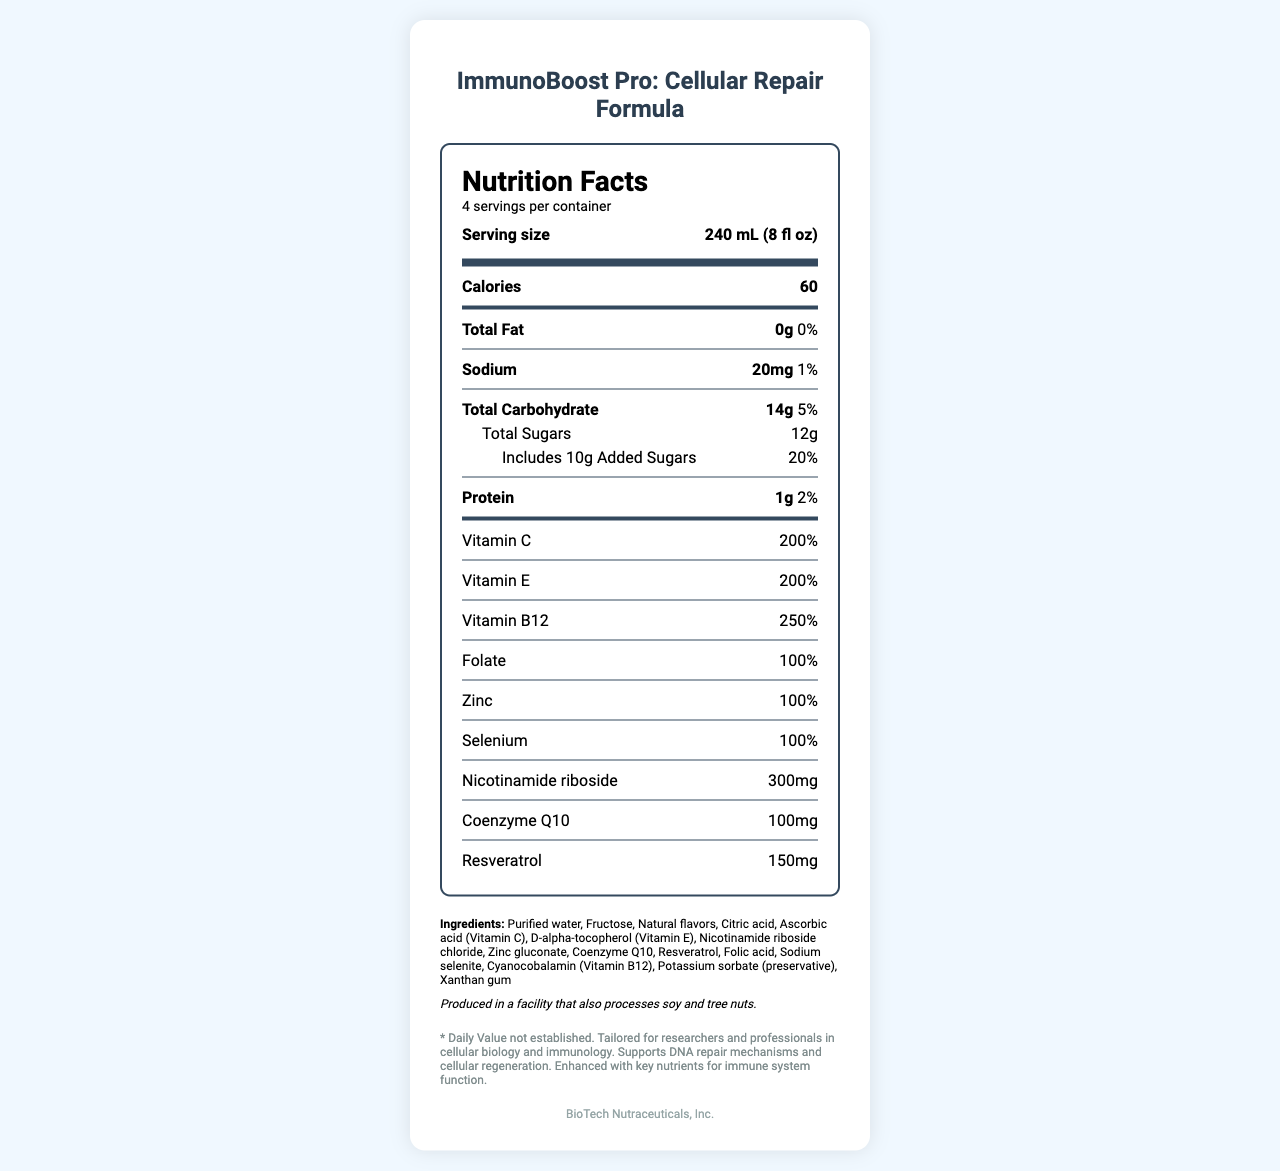what is the serving size? The serving size is displayed at the top of the Nutrition Facts label under "Serving size".
Answer: 240 mL (8 fl oz) how many calories are in one serving? The number of calories per serving is listed near the top of the Nutrition Facts section.
Answer: 60 name three vitamins found in this product and their daily values. The daily values for Vitamin C, Vitamin E, and Vitamin B12 are clearly listed in the vitamins section of the label.
Answer: Vitamin C (200%), Vitamin E (200%), Vitamin B12 (250%) what is the total fat content per serving? The total fat content per serving is listed as 0g.
Answer: 0g how many grams of sugar are added sugars? The document specifies that 10g of the total sugars are added sugars.
Answer: 10g how many servings are in one container? The number of servings per container is listed as 4.
Answer: 4 what are the ingredients in the product? All the ingredients are listed under the "Ingredients" section of the label.
Answer: Purified water, Fructose, Natural flavors, Citric acid, Ascorbic acid (Vitamin C), D-alpha-tocopherol (Vitamin E), Nicotinamide riboside chloride, Zinc gluconate, Coenzyme Q10, Resveratrol, Folic acid, Sodium selenite, Cyanocobalamin (Vitamin B12), Potassium sorbate (preservative), Xanthan gum what is the daily value percentage of protein in one serving? The daily value percentage for protein is listed as 2% in the Nutrition Facts.
Answer: 2% which vitamin has the highest percentage of daily value in one serving? A. Vitamin C B. Vitamin E C. Vitamin B12 The daily value percentage for Vitamin B12 is 250%, which is higher than both Vitamin C (200%) and Vitamin E (200%).
Answer: C. Vitamin B12 what is the daily value percentage for sodium? A. 0.5% B. 1% C. 2% D. 5% The daily value percentage for sodium is listed as 1%.
Answer: B. 1% does this product contain any fat? The total fat content is listed as 0g.
Answer: No summarize the main purpose of this product. The product description and special notes sections indicate that the beverage is aimed at supporting cellular regeneration and DNA repair, with a high concentration of vitamins and specific nutrients.
Answer: ImmunoBoost Pro: Cellular Repair Formula is a vitamin-fortified beverage designed to support cellular regeneration and DNA repair, tailored for researchers and professionals in cellular biology and immunology. It provides a significant amount of essential vitamins and nutrients that boost the immune system and assist in DNA repair mechanisms. what is the amount of Nicotinamide riboside in one serving, and what is its daily value percentage? The amount of Nicotinamide riboside per serving is listed as 300mg, and the daily value percentage is marked with an asterisk indicating it is not established.
Answer: 300mg, Daily Value not established. is Vitamin B12 listed in the ingredients? Vitamin B12 is found in the ingredients section as Cyanocobalamin (Vitamin B12).
Answer: Yes what facility-related allergen info is noted on the label? The allergen information states that the product is produced in a facility that also processes soy and tree nuts.
Answer: Produced in a facility that also processes soy and tree nuts. identify the manufacturer of the product. The manufacturer information is listed at the bottom of the label.
Answer: BioTech Nutraceuticals, Inc. is this product more suitable for general health or specific research purposes? The special notes indicate that the product is tailored for researchers and professionals in cellular biology and immunology, supporting DNA repair and cellular regeneration.
Answer: Specific research purposes what are the benefits of nicotinamide riboside included in the formula? The specific benefits of nicotinamide riboside are not detailed in the visual information of the document.
Answer: Not enough information how many grams of total carbohydrates are in one serving? The total carbohydrates per serving are listed as 14g in the Nutrition Facts.
Answer: 14g 